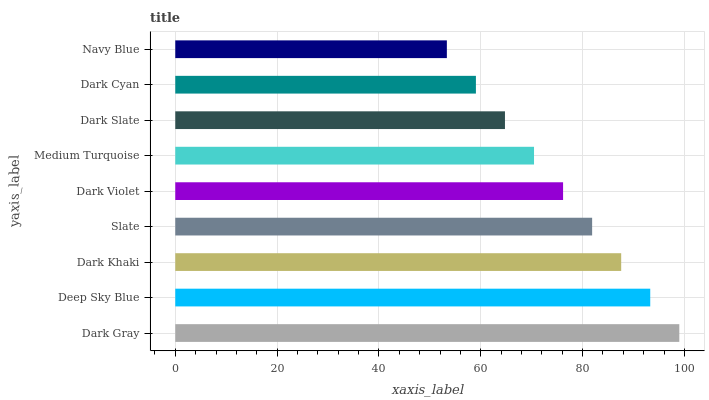Is Navy Blue the minimum?
Answer yes or no. Yes. Is Dark Gray the maximum?
Answer yes or no. Yes. Is Deep Sky Blue the minimum?
Answer yes or no. No. Is Deep Sky Blue the maximum?
Answer yes or no. No. Is Dark Gray greater than Deep Sky Blue?
Answer yes or no. Yes. Is Deep Sky Blue less than Dark Gray?
Answer yes or no. Yes. Is Deep Sky Blue greater than Dark Gray?
Answer yes or no. No. Is Dark Gray less than Deep Sky Blue?
Answer yes or no. No. Is Dark Violet the high median?
Answer yes or no. Yes. Is Dark Violet the low median?
Answer yes or no. Yes. Is Slate the high median?
Answer yes or no. No. Is Dark Slate the low median?
Answer yes or no. No. 